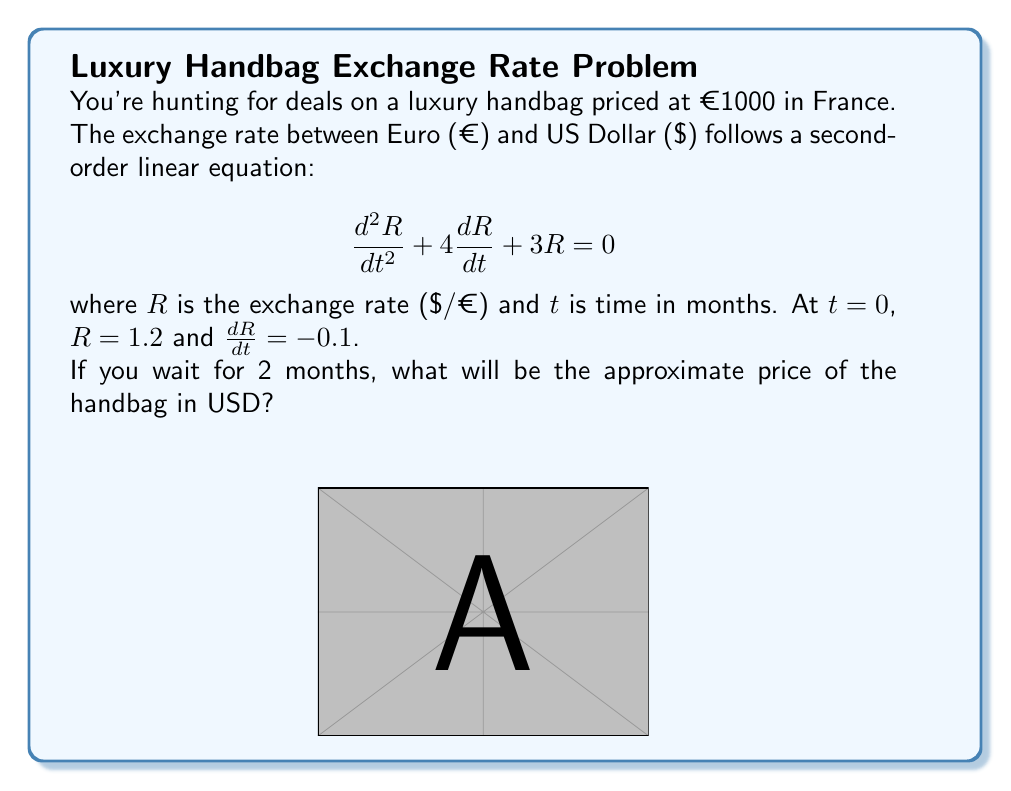Show me your answer to this math problem. To solve this problem, we need to follow these steps:

1) First, we need to solve the second-order linear equation. The characteristic equation is:
   $$r^2 + 4r + 3 = 0$$
   
2) Solving this equation:
   $$(r+1)(r+3) = 0$$
   $r = -1$ or $r = -3$

3) The general solution is:
   $$R(t) = C_1e^{-t} + C_2e^{-3t}$$

4) Using the initial conditions:
   At $t=0$: $R(0) = 1.2 = C_1 + C_2$
   At $t=0$: $R'(0) = -0.1 = -C_1 - 3C_2$

5) Solving these equations:
   $C_1 = 1.35$ and $C_2 = -0.15$

6) Therefore, the exchange rate function is:
   $$R(t) = 1.35e^{-t} - 0.15e^{-3t}$$

7) At $t=2$ months:
   $$R(2) = 1.35e^{-2} - 0.15e^{-6} \approx 0.9968$$

8) The price of the handbag in USD after 2 months will be:
   $$1000 \times 0.9968 \approx 996.80$$
Answer: $996.80 